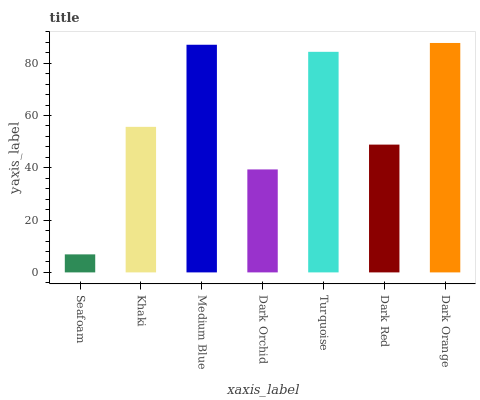Is Dark Orange the maximum?
Answer yes or no. Yes. Is Khaki the minimum?
Answer yes or no. No. Is Khaki the maximum?
Answer yes or no. No. Is Khaki greater than Seafoam?
Answer yes or no. Yes. Is Seafoam less than Khaki?
Answer yes or no. Yes. Is Seafoam greater than Khaki?
Answer yes or no. No. Is Khaki less than Seafoam?
Answer yes or no. No. Is Khaki the high median?
Answer yes or no. Yes. Is Khaki the low median?
Answer yes or no. Yes. Is Dark Red the high median?
Answer yes or no. No. Is Seafoam the low median?
Answer yes or no. No. 